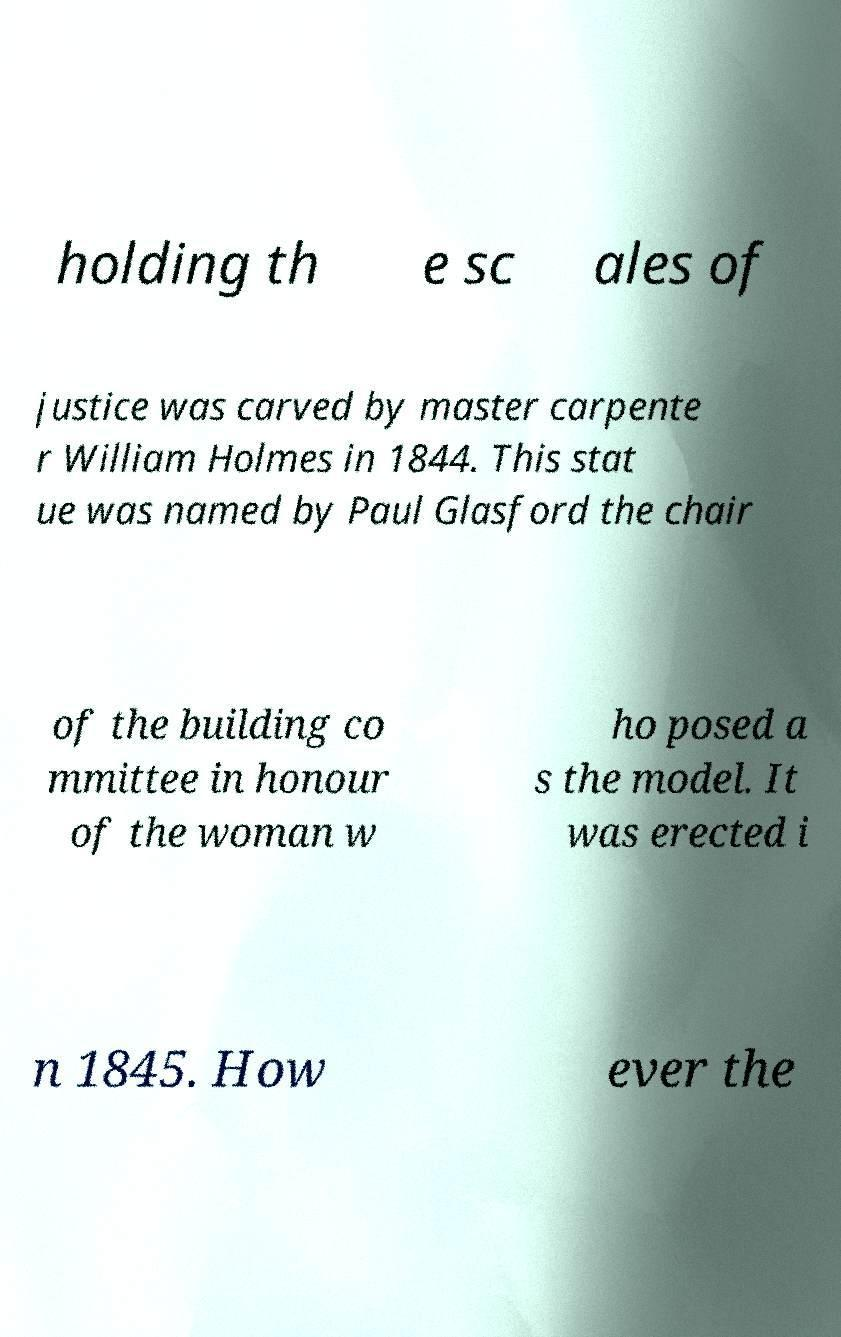Can you accurately transcribe the text from the provided image for me? holding th e sc ales of justice was carved by master carpente r William Holmes in 1844. This stat ue was named by Paul Glasford the chair of the building co mmittee in honour of the woman w ho posed a s the model. It was erected i n 1845. How ever the 